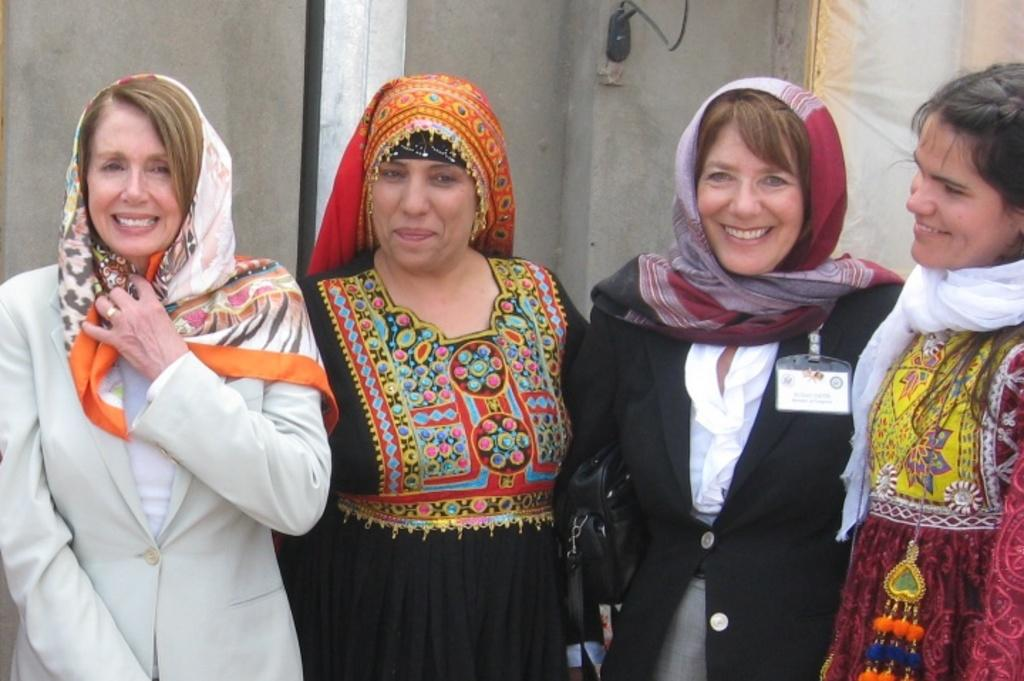How many people are in the image? There are four women in the image. What are the women doing in the image? The women are standing with smiles on their faces. Can you describe anything in the background of the image? There is an object with a cable on the wall in the background. What type of toys can be seen in the hands of the women in the image? There are no toys visible in the image; the women are not holding anything in their hands. 